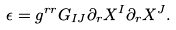Convert formula to latex. <formula><loc_0><loc_0><loc_500><loc_500>\epsilon = g ^ { r r } G _ { I J } \partial _ { r } X ^ { I } \partial _ { r } X ^ { J } .</formula> 